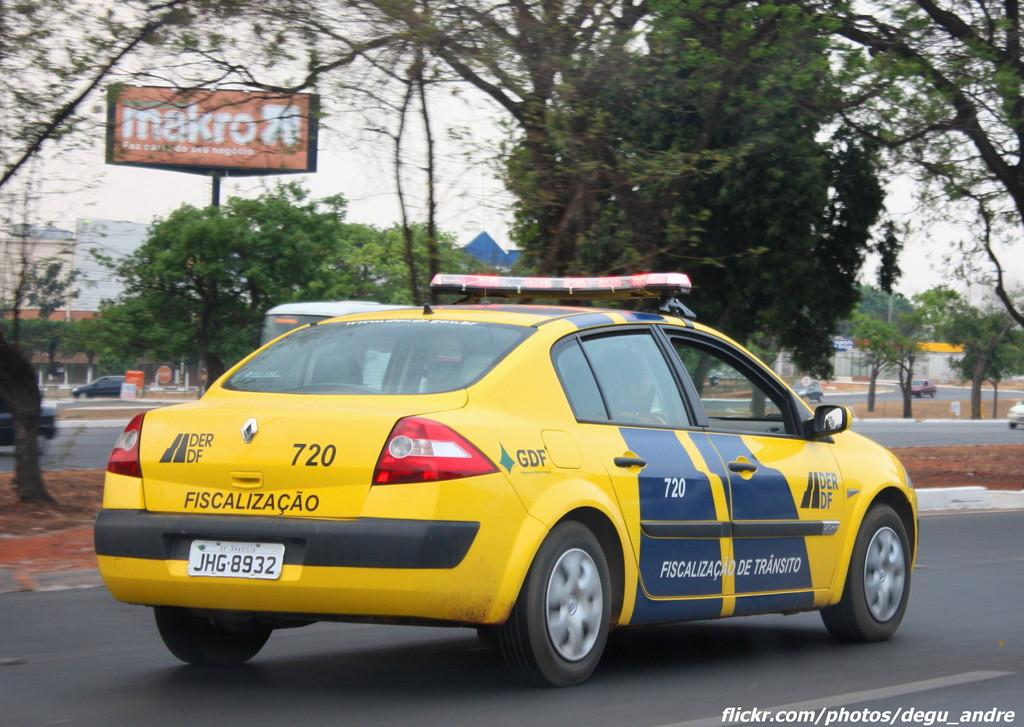<image>
Share a concise interpretation of the image provided. a transit prosecutor car with the number 720 